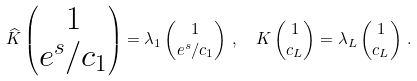<formula> <loc_0><loc_0><loc_500><loc_500>\widehat { K } \begin{pmatrix} 1 \\ e ^ { s } / c _ { 1 } \end{pmatrix} & = \lambda _ { 1 } \begin{pmatrix} 1 \\ e ^ { s } / c _ { 1 } \end{pmatrix} \, , \quad K \begin{pmatrix} 1 \\ c _ { L } \end{pmatrix} = \lambda _ { L } \begin{pmatrix} 1 \\ c _ { L } \end{pmatrix} \, .</formula> 